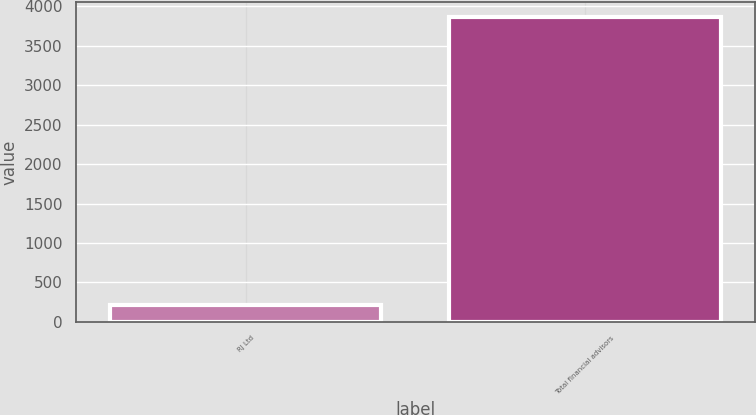Convert chart to OTSL. <chart><loc_0><loc_0><loc_500><loc_500><bar_chart><fcel>RJ Ltd<fcel>Total financial advisors<nl><fcel>216<fcel>3858<nl></chart> 